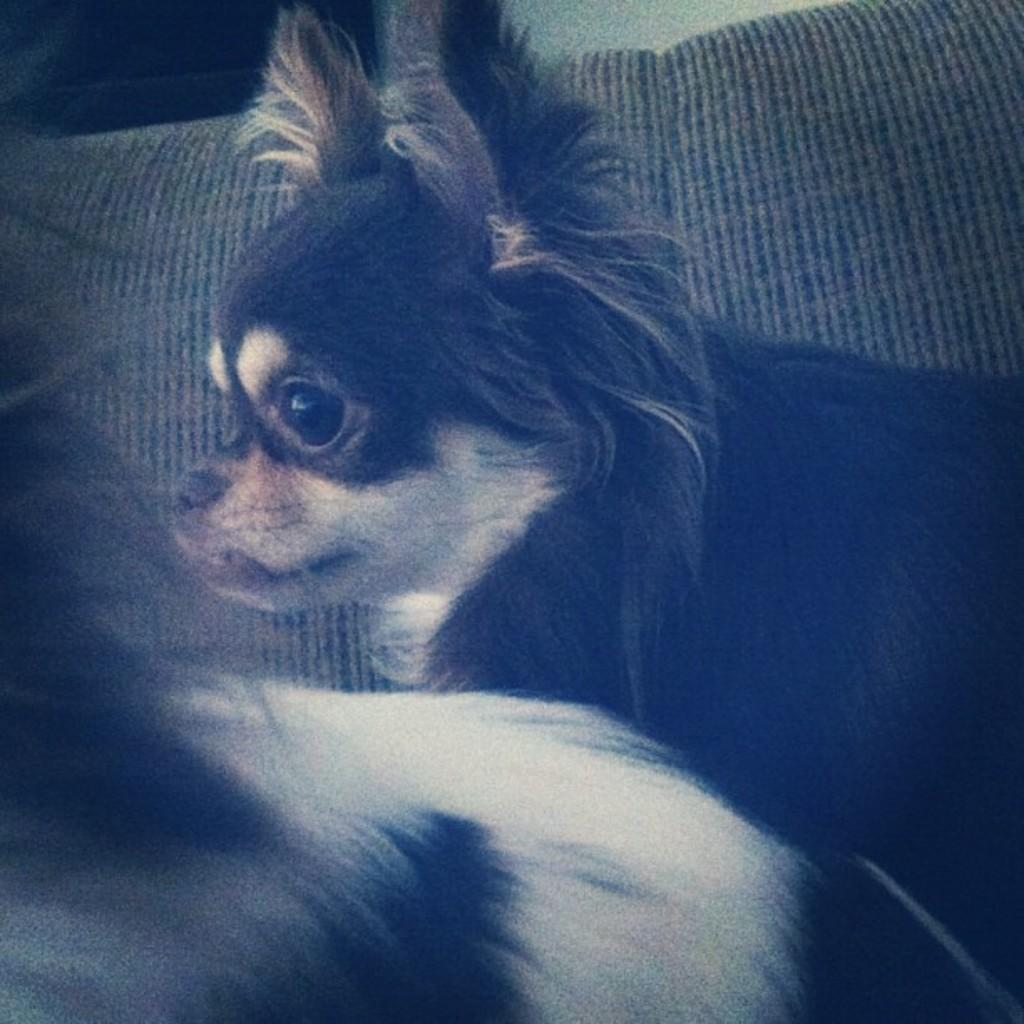How many dogs are present in the image? There are two dogs in the image. Can you describe the objects in the background of the image? Unfortunately, the provided facts do not give any information about the objects in the background. What type of crack is visible on the fold of the trip in the image? There is no trip, crack, or fold present in the image. The image only features two dogs. 